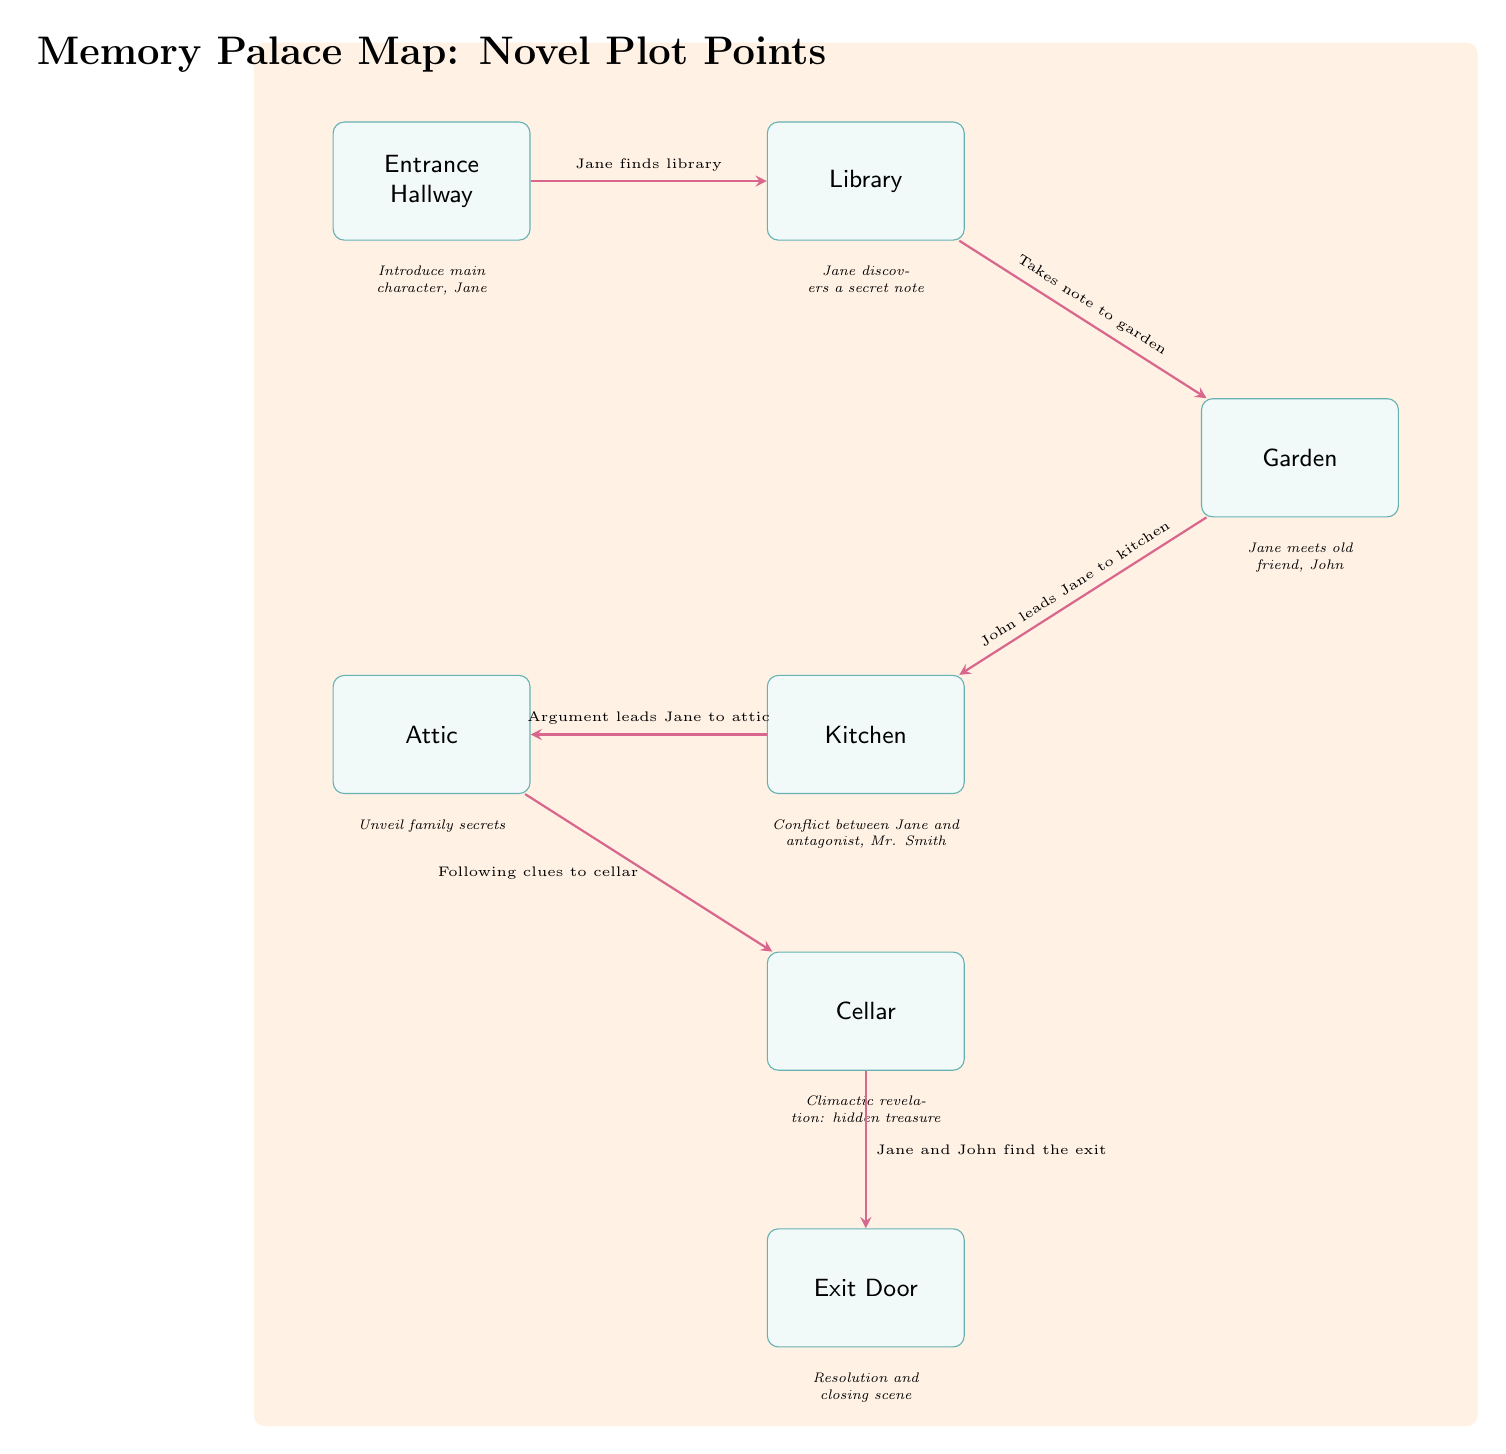What is the first location in the Memory Palace? The diagram shows the Entrance Hallway as the starting point at the top of the Memory Palace. Therefore, the first location is identified as the Entrance Hallway.
Answer: Entrance Hallway How many total locations are included in the Memory Palace Map? Counting the boxes in the diagram, we see there are seven locations: Entrance Hallway, Library, Garden, Kitchen, Attic, Cellar, and Exit Door, which means the total is seven.
Answer: 7 What does Jane discover in the Library? The diagram indicates that in the Library, Jane discovers a secret note. Therefore, the answer to this inquiry is directly extracted from the label associated with the Library node.
Answer: a secret note Which character does Jane meet in the Garden? According to the diagram, Jane meets her old friend, John, in the Garden. This information is directly provided in the description below the Garden node.
Answer: John Where does the conflict between Jane and Mr. Smith occur? The diagram specifies that the conflict takes place in the Kitchen. By looking at the description beneath the Kitchen node, we identify that it is where the argument occurs.
Answer: Kitchen What is the purpose of the Exit Door in the plot? The diagram reveals that the Exit Door signifies the resolution and closing scene of the novel. This function is specified in the description accompanying the Exit Door location.
Answer: Resolution and closing scene How does Jane's journey progress from the Garden to the Kitchen? The arrow connecting the Garden and Kitchen is labeled "John leads Jane to kitchen," indicating the transition caused by John's guidance after their meeting in the Garden. This relationship helps to understand how the journey unfolds.
Answer: John leads Jane to kitchen Which location precedes the Cellar in Jane's exploration? The diagram reveals a sequential path where the Attic comes before the Cellar, as denoted by the arrow leading from the Attic to the Cellar. Therefore, this order is clear in the overall flow of locations.
Answer: Attic What key event occurs in the Cellar? The description below the Cellar states that the climactic revelation of a hidden treasure occurs here. This significant plot point is the core of the Cellar's role in the narrative.
Answer: hidden treasure 